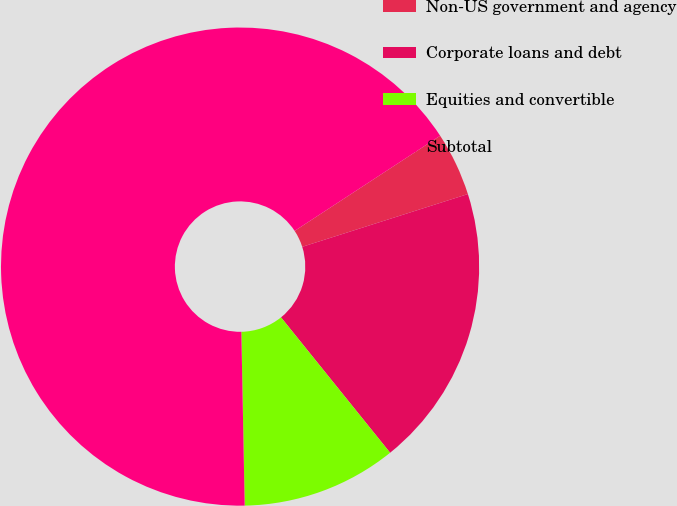Convert chart. <chart><loc_0><loc_0><loc_500><loc_500><pie_chart><fcel>Non-US government and agency<fcel>Corporate loans and debt<fcel>Equities and convertible<fcel>Subtotal<nl><fcel>4.31%<fcel>19.11%<fcel>10.49%<fcel>66.09%<nl></chart> 